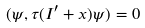Convert formula to latex. <formula><loc_0><loc_0><loc_500><loc_500>( \psi , \tau ( I ^ { \prime } + x ) \psi ) = 0</formula> 